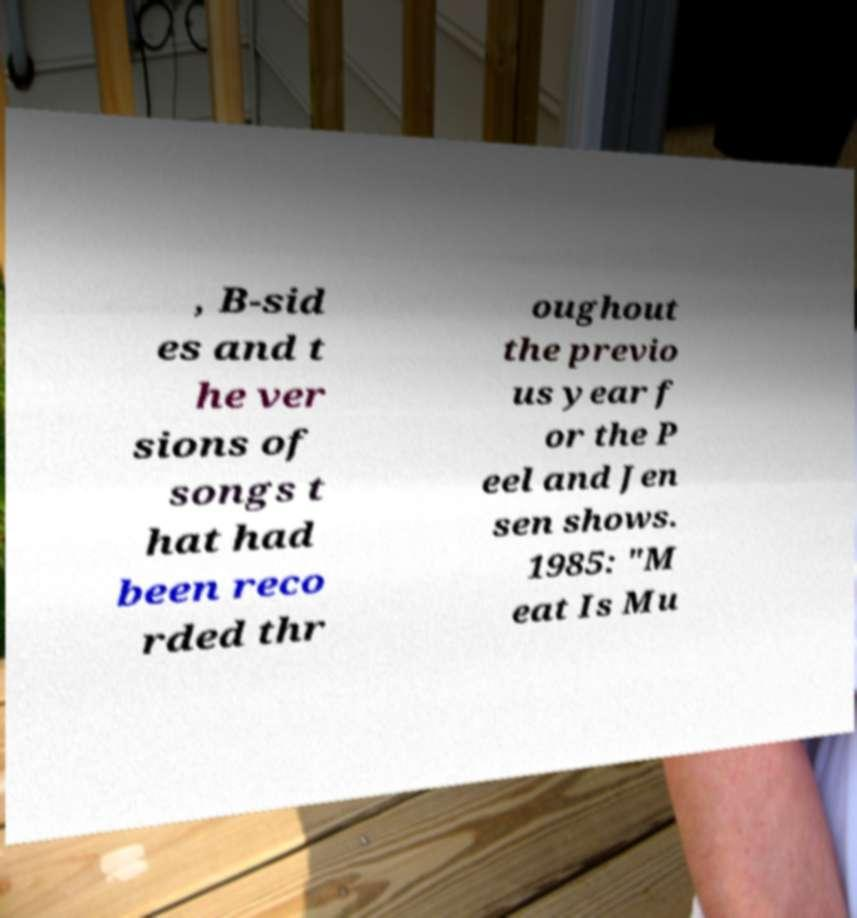Can you read and provide the text displayed in the image?This photo seems to have some interesting text. Can you extract and type it out for me? , B-sid es and t he ver sions of songs t hat had been reco rded thr oughout the previo us year f or the P eel and Jen sen shows. 1985: "M eat Is Mu 